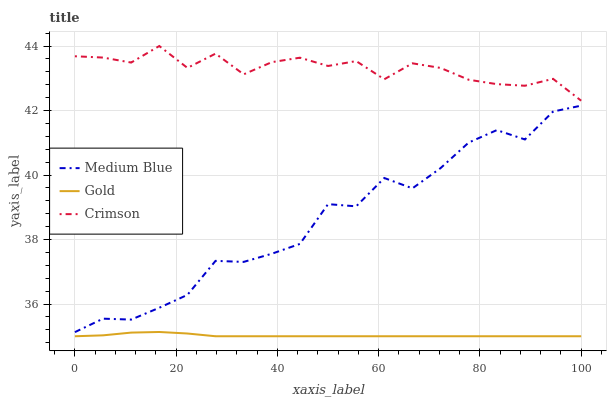Does Gold have the minimum area under the curve?
Answer yes or no. Yes. Does Crimson have the maximum area under the curve?
Answer yes or no. Yes. Does Medium Blue have the minimum area under the curve?
Answer yes or no. No. Does Medium Blue have the maximum area under the curve?
Answer yes or no. No. Is Gold the smoothest?
Answer yes or no. Yes. Is Medium Blue the roughest?
Answer yes or no. Yes. Is Medium Blue the smoothest?
Answer yes or no. No. Is Gold the roughest?
Answer yes or no. No. Does Gold have the lowest value?
Answer yes or no. Yes. Does Medium Blue have the lowest value?
Answer yes or no. No. Does Crimson have the highest value?
Answer yes or no. Yes. Does Medium Blue have the highest value?
Answer yes or no. No. Is Medium Blue less than Crimson?
Answer yes or no. Yes. Is Medium Blue greater than Gold?
Answer yes or no. Yes. Does Medium Blue intersect Crimson?
Answer yes or no. No. 